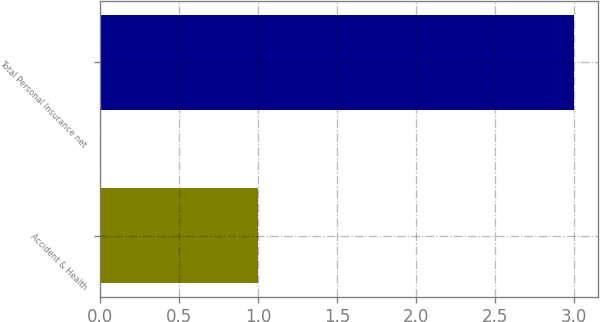Convert chart to OTSL. <chart><loc_0><loc_0><loc_500><loc_500><bar_chart><fcel>Accident & Health<fcel>Total Personal Insurance net<nl><fcel>1<fcel>3<nl></chart> 